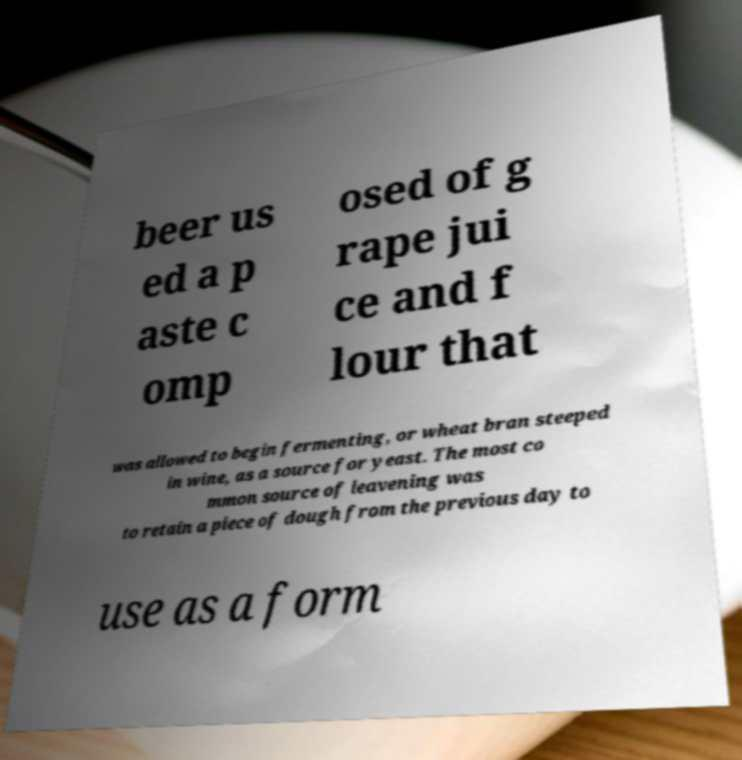Can you accurately transcribe the text from the provided image for me? beer us ed a p aste c omp osed of g rape jui ce and f lour that was allowed to begin fermenting, or wheat bran steeped in wine, as a source for yeast. The most co mmon source of leavening was to retain a piece of dough from the previous day to use as a form 